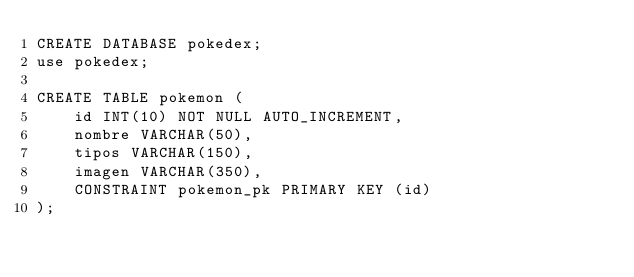<code> <loc_0><loc_0><loc_500><loc_500><_SQL_>CREATE DATABASE pokedex;
use pokedex;

CREATE TABLE pokemon (
	id INT(10) NOT NULL AUTO_INCREMENT,
	nombre VARCHAR(50),
	tipos VARCHAR(150),
	imagen VARCHAR(350),
	CONSTRAINT pokemon_pk PRIMARY KEY (id)
);</code> 